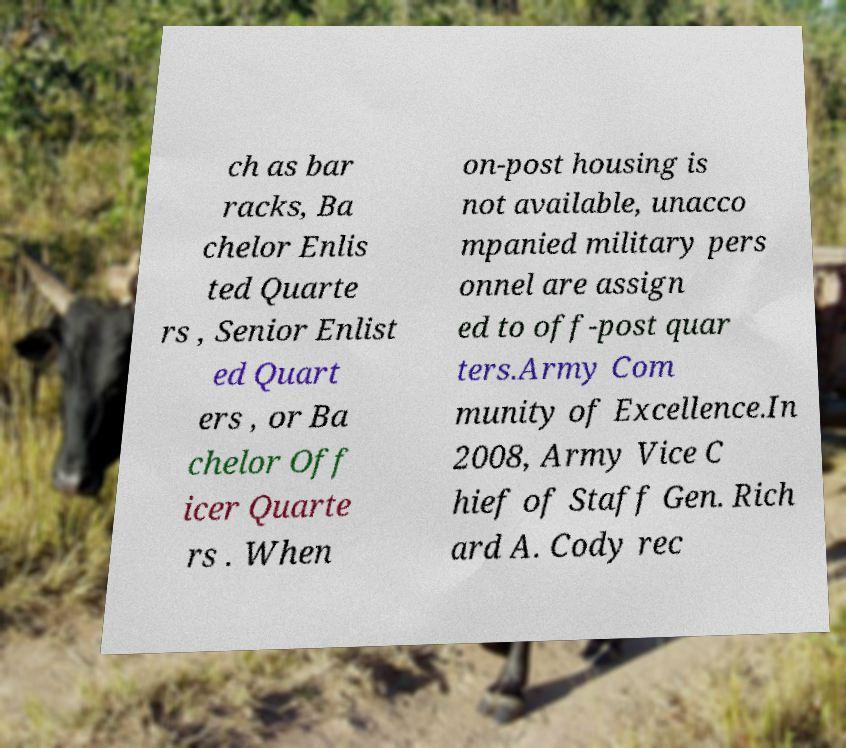For documentation purposes, I need the text within this image transcribed. Could you provide that? ch as bar racks, Ba chelor Enlis ted Quarte rs , Senior Enlist ed Quart ers , or Ba chelor Off icer Quarte rs . When on-post housing is not available, unacco mpanied military pers onnel are assign ed to off-post quar ters.Army Com munity of Excellence.In 2008, Army Vice C hief of Staff Gen. Rich ard A. Cody rec 